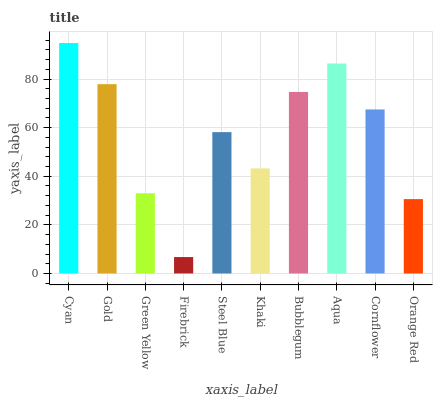Is Firebrick the minimum?
Answer yes or no. Yes. Is Cyan the maximum?
Answer yes or no. Yes. Is Gold the minimum?
Answer yes or no. No. Is Gold the maximum?
Answer yes or no. No. Is Cyan greater than Gold?
Answer yes or no. Yes. Is Gold less than Cyan?
Answer yes or no. Yes. Is Gold greater than Cyan?
Answer yes or no. No. Is Cyan less than Gold?
Answer yes or no. No. Is Cornflower the high median?
Answer yes or no. Yes. Is Steel Blue the low median?
Answer yes or no. Yes. Is Orange Red the high median?
Answer yes or no. No. Is Firebrick the low median?
Answer yes or no. No. 